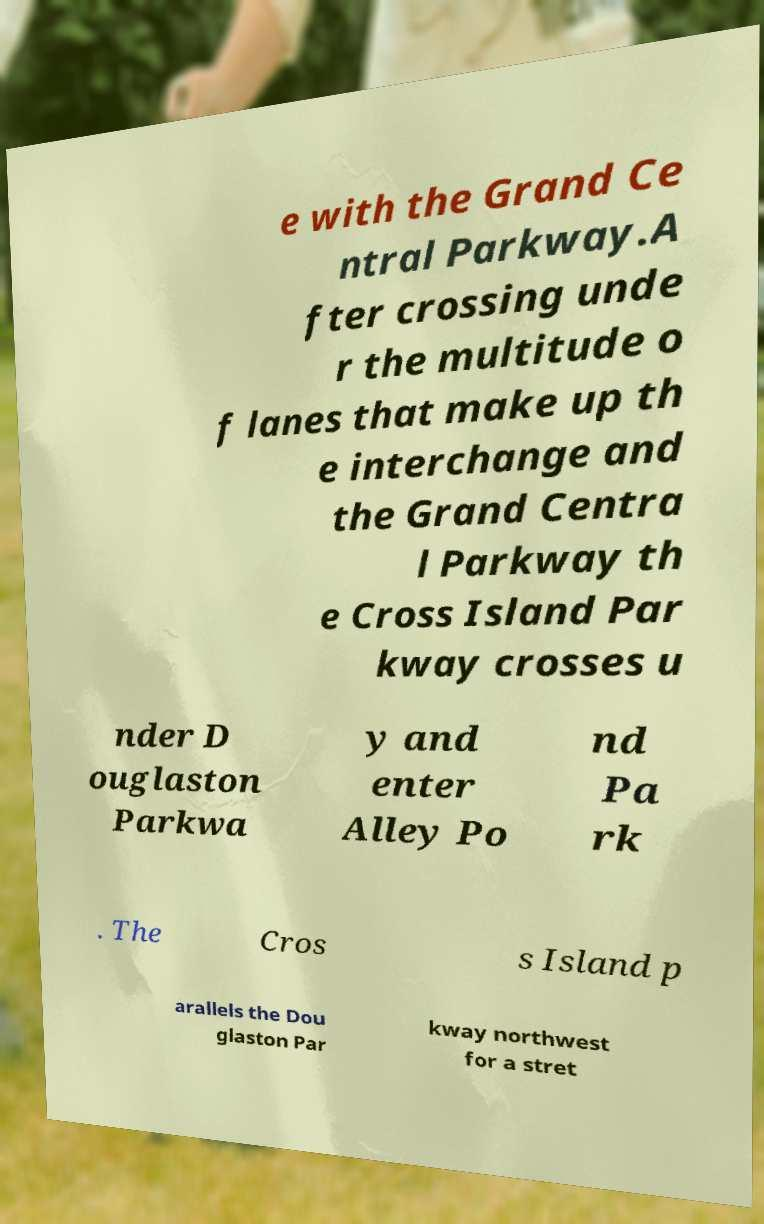Could you assist in decoding the text presented in this image and type it out clearly? e with the Grand Ce ntral Parkway.A fter crossing unde r the multitude o f lanes that make up th e interchange and the Grand Centra l Parkway th e Cross Island Par kway crosses u nder D ouglaston Parkwa y and enter Alley Po nd Pa rk . The Cros s Island p arallels the Dou glaston Par kway northwest for a stret 